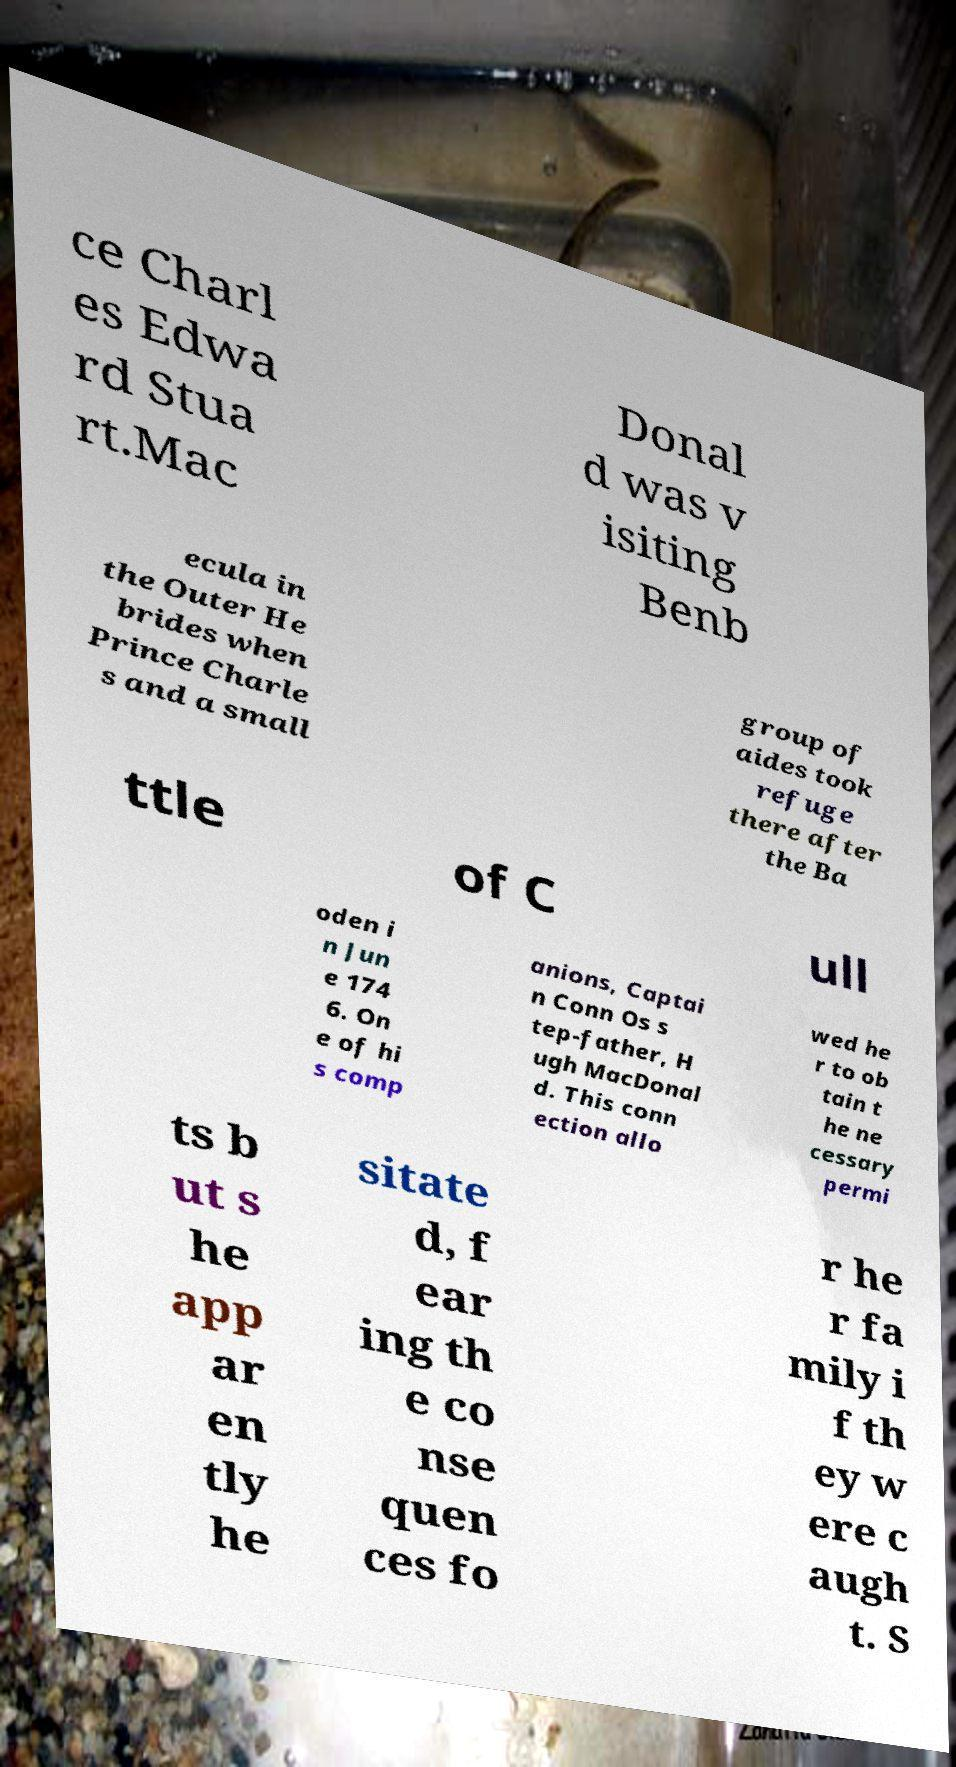Can you read and provide the text displayed in the image?This photo seems to have some interesting text. Can you extract and type it out for me? ce Charl es Edwa rd Stua rt.Mac Donal d was v isiting Benb ecula in the Outer He brides when Prince Charle s and a small group of aides took refuge there after the Ba ttle of C ull oden i n Jun e 174 6. On e of hi s comp anions, Captai n Conn Os s tep-father, H ugh MacDonal d. This conn ection allo wed he r to ob tain t he ne cessary permi ts b ut s he app ar en tly he sitate d, f ear ing th e co nse quen ces fo r he r fa mily i f th ey w ere c augh t. S 